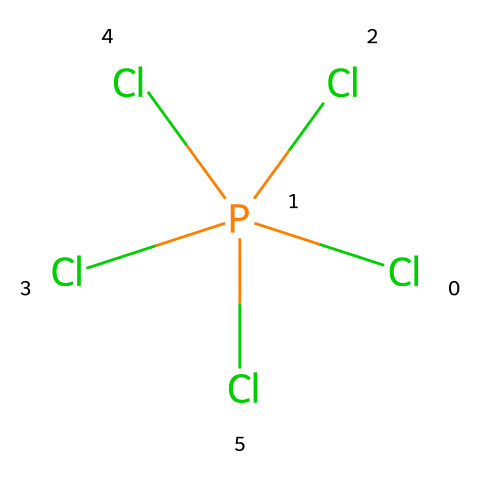What is the central atom in this compound? The structure shows phosphorus (P) at the center, bonded to five chlorine (Cl) atoms. This indicates phosphorus is the central atom.
Answer: phosphorus How many chlorine atoms are bonded to phosphorus in this compound? The visual representation indicates there are five chlorine (Cl) atoms bonded to the phosphorus (P) atom.
Answer: five What type of hybridization does phosphorus exhibit in phosphorus pentachloride? In phosphorus pentachloride, phosphorus undergoes sp3d hybridization due to its bonding with five chlorine atoms, which accommodates five electron pairs.
Answer: sp3d What is the primary characteristic of hypervalent compounds such as phosphorus pentachloride? Hypervalent compounds such as phosphorus pentachloride have more bonds than traditional octet rule allows, capable of expanding their valence shell beyond eight electrons.
Answer: more than eight What role might phosphorus pentachloride play in perlite expansion processes? Phosphorus pentachloride can act as a catalyst to facilitate reactions, likely enhancing the thermal expansion of perlite through its chemical reactivity.
Answer: catalyst Which type of compound is phosphorus pentachloride classified as? Phosphorus pentachloride is classified as a hypervalent compound due to its ability to form bonds exceeding the octet rule with phosphorus at the center.
Answer: hypervalent 